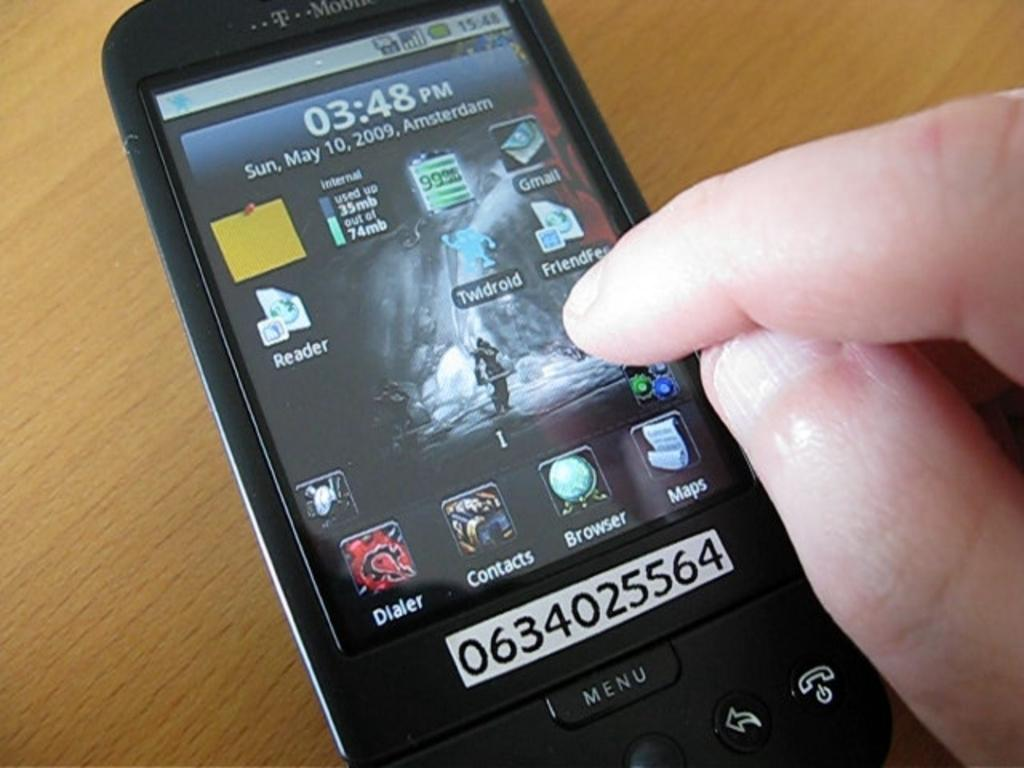<image>
Share a concise interpretation of the image provided. A Person is touching their phone that is numbered 0634025564 on the bottom above the menu. 